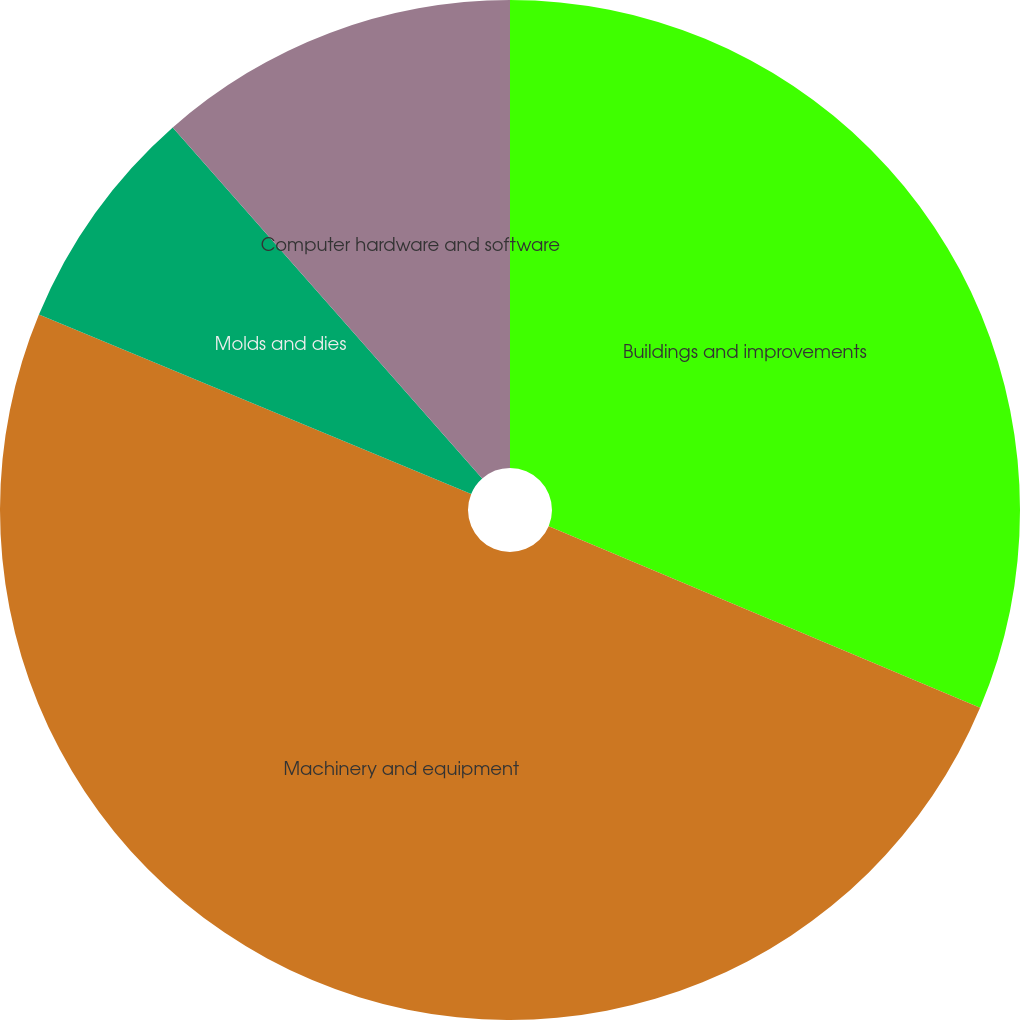Convert chart to OTSL. <chart><loc_0><loc_0><loc_500><loc_500><pie_chart><fcel>Buildings and improvements<fcel>Machinery and equipment<fcel>Molds and dies<fcel>Computer hardware and software<nl><fcel>31.34%<fcel>49.92%<fcel>7.24%<fcel>11.5%<nl></chart> 